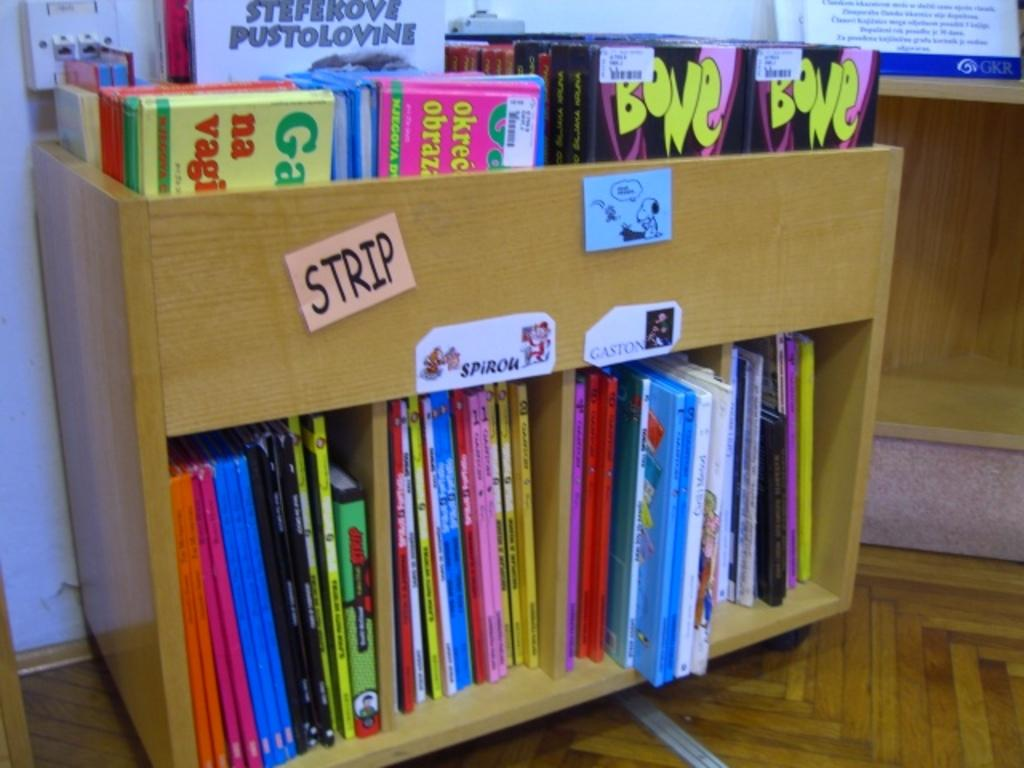<image>
Present a compact description of the photo's key features. Book shelf that says STRIP on a small piece of paper. 